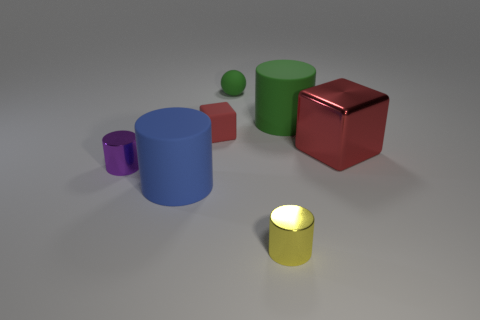Subtract 1 cylinders. How many cylinders are left? 3 Add 1 yellow cylinders. How many objects exist? 8 Subtract all balls. How many objects are left? 6 Add 4 blue things. How many blue things exist? 5 Subtract 0 yellow cubes. How many objects are left? 7 Subtract all cylinders. Subtract all tiny cyan shiny objects. How many objects are left? 3 Add 2 red metal blocks. How many red metal blocks are left? 3 